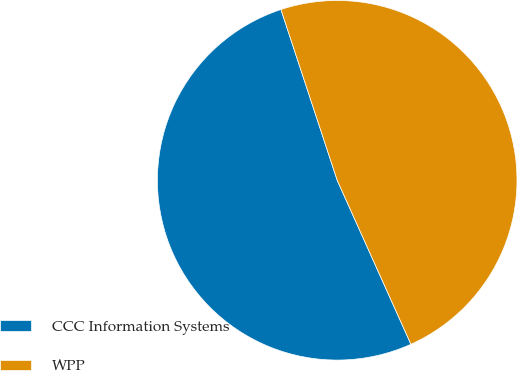<chart> <loc_0><loc_0><loc_500><loc_500><pie_chart><fcel>CCC Information Systems<fcel>WPP<nl><fcel>51.66%<fcel>48.34%<nl></chart> 